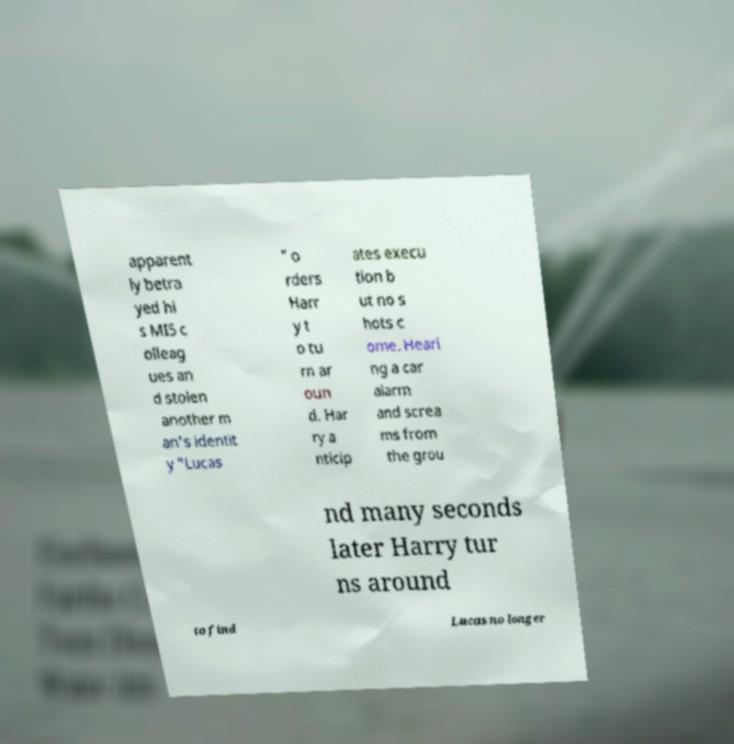For documentation purposes, I need the text within this image transcribed. Could you provide that? apparent ly betra yed hi s MI5 c olleag ues an d stolen another m an's identit y "Lucas " o rders Harr y t o tu rn ar oun d. Har ry a nticip ates execu tion b ut no s hots c ome. Heari ng a car alarm and screa ms from the grou nd many seconds later Harry tur ns around to find Lucas no longer 